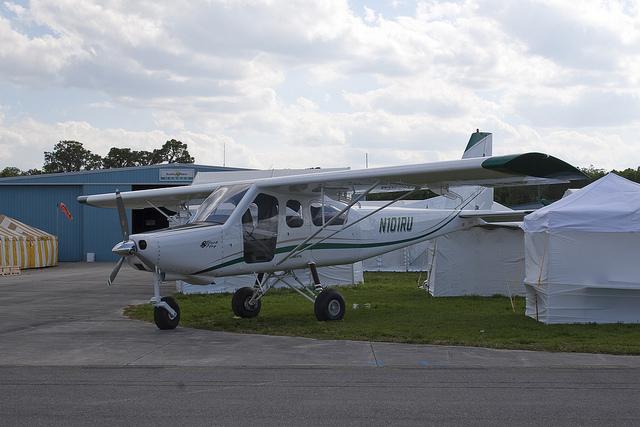Does it have a propeller?
Concise answer only. Yes. Is it at an airport?
Quick response, please. Yes. What color is the plane?
Write a very short answer. White. 